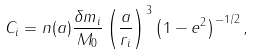Convert formula to latex. <formula><loc_0><loc_0><loc_500><loc_500>C _ { i } = n ( a ) \frac { \delta m _ { i } } { M _ { 0 } } \left ( \frac { a } { r _ { i } } \right ) ^ { 3 } \left ( 1 - e ^ { 2 } \right ) ^ { - 1 / 2 } ,</formula> 